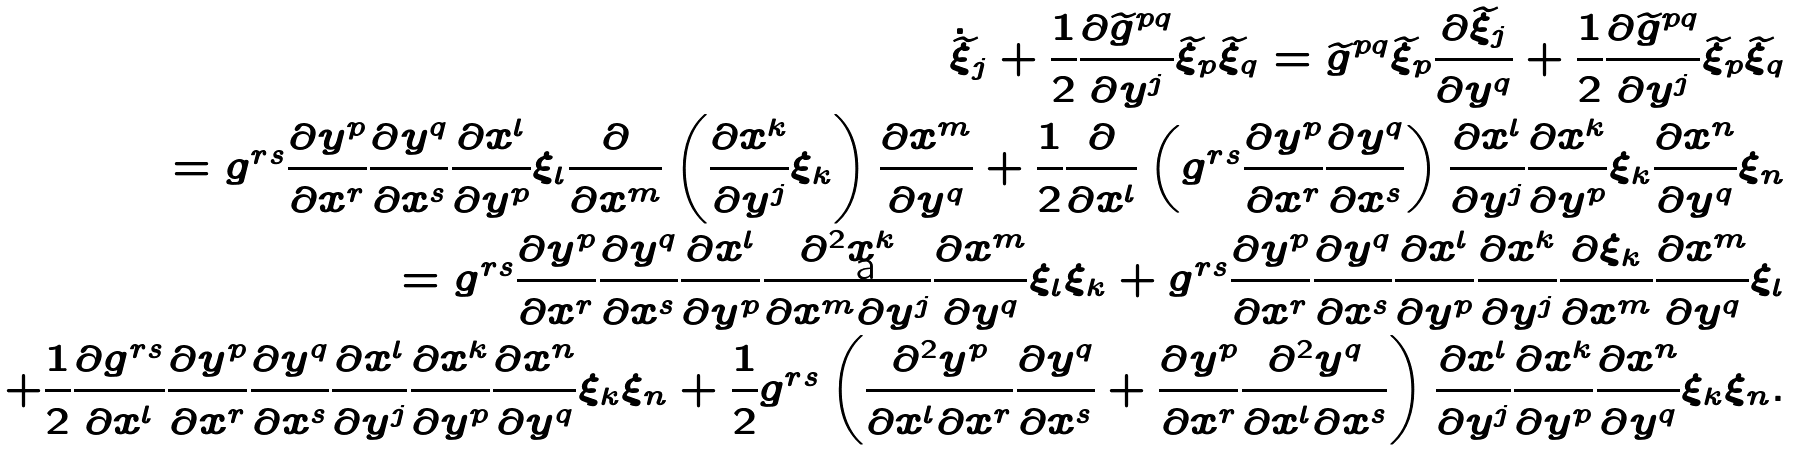Convert formula to latex. <formula><loc_0><loc_0><loc_500><loc_500>\dot { \widetilde { \xi } } _ { j } + \frac { 1 } { 2 } \frac { \partial \widetilde { g } ^ { p q } } { \partial y ^ { j } } \widetilde { \xi } _ { p } \widetilde { \xi } _ { q } = \widetilde { g } ^ { p q } \widetilde { \xi } _ { p } \frac { \partial \widetilde { \xi } _ { j } } { \partial y ^ { q } } + \frac { 1 } { 2 } \frac { \partial \widetilde { g } ^ { p q } } { \partial y ^ { j } } \widetilde { \xi } _ { p } \widetilde { \xi } _ { q } \\ = g ^ { r s } \frac { \partial y ^ { p } } { \partial x ^ { r } } \frac { \partial y ^ { q } } { \partial x ^ { s } } \frac { \partial x ^ { l } } { \partial y ^ { p } } \xi _ { l } \frac { \partial } { \partial x ^ { m } } \left ( \frac { \partial x ^ { k } } { \partial y ^ { j } } \xi _ { k } \right ) \frac { \partial x ^ { m } } { \partial y ^ { q } } + \frac { 1 } { 2 } \frac { \partial } { \partial x ^ { l } } \left ( g ^ { r s } \frac { \partial y ^ { p } } { \partial x ^ { r } } \frac { \partial y ^ { q } } { \partial x ^ { s } } \right ) \frac { \partial x ^ { l } } { \partial y ^ { j } } \frac { \partial x ^ { k } } { \partial y ^ { p } } \xi _ { k } \frac { \partial x ^ { n } } { \partial y ^ { q } } \xi _ { n } \\ = g ^ { r s } \frac { \partial y ^ { p } } { \partial x ^ { r } } \frac { \partial y ^ { q } } { \partial x ^ { s } } \frac { \partial x ^ { l } } { \partial y ^ { p } } \frac { \partial ^ { 2 } x ^ { k } } { \partial x ^ { m } \partial y ^ { j } } \frac { \partial x ^ { m } } { \partial y ^ { q } } \xi _ { l } \xi _ { k } + g ^ { r s } \frac { \partial y ^ { p } } { \partial x ^ { r } } \frac { \partial y ^ { q } } { \partial x ^ { s } } \frac { \partial x ^ { l } } { \partial y ^ { p } } \frac { \partial x ^ { k } } { \partial y ^ { j } } \frac { \partial \xi _ { k } } { \partial x ^ { m } } \frac { \partial x ^ { m } } { \partial y ^ { q } } \xi _ { l } \\ + \frac { 1 } { 2 } \frac { \partial g ^ { r s } } { \partial x ^ { l } } \frac { \partial y ^ { p } } { \partial x ^ { r } } \frac { \partial y ^ { q } } { \partial x ^ { s } } \frac { \partial x ^ { l } } { \partial y ^ { j } } \frac { \partial x ^ { k } } { \partial y ^ { p } } \frac { \partial x ^ { n } } { \partial y ^ { q } } \xi _ { k } \xi _ { n } + \frac { 1 } { 2 } g ^ { r s } \left ( \frac { \partial ^ { 2 } y ^ { p } } { \partial x ^ { l } \partial x ^ { r } } \frac { \partial y ^ { q } } { \partial x ^ { s } } + \frac { \partial y ^ { p } } { \partial x ^ { r } } \frac { \partial ^ { 2 } y ^ { q } } { \partial x ^ { l } \partial x ^ { s } } \right ) \frac { \partial x ^ { l } } { \partial y ^ { j } } \frac { \partial x ^ { k } } { \partial y ^ { p } } \frac { \partial x ^ { n } } { \partial y ^ { q } } \xi _ { k } \xi _ { n } .</formula> 